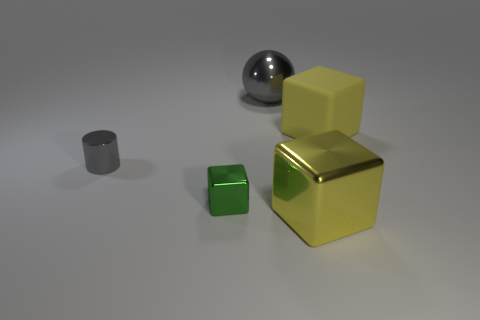How many balls have the same size as the green shiny object?
Make the answer very short. 0. What is the big object that is behind the big metal cube and in front of the large gray shiny sphere made of?
Keep it short and to the point. Rubber. What material is the cube that is the same size as the gray metal cylinder?
Offer a very short reply. Metal. There is a gray shiny thing that is behind the gray metallic object that is in front of the gray thing to the right of the cylinder; what size is it?
Make the answer very short. Large. The other gray object that is made of the same material as the tiny gray object is what size?
Your answer should be compact. Large. There is a sphere; is it the same size as the gray metal object in front of the ball?
Give a very brief answer. No. There is a gray metal object in front of the big gray thing; what is its shape?
Provide a succinct answer. Cylinder. There is a big cube that is on the right side of the big yellow cube in front of the yellow matte cube; is there a big yellow cube on the right side of it?
Your answer should be compact. No. What is the material of the tiny green object that is the same shape as the big rubber thing?
Your answer should be very brief. Metal. Are there any other things that have the same material as the small cylinder?
Make the answer very short. Yes. 